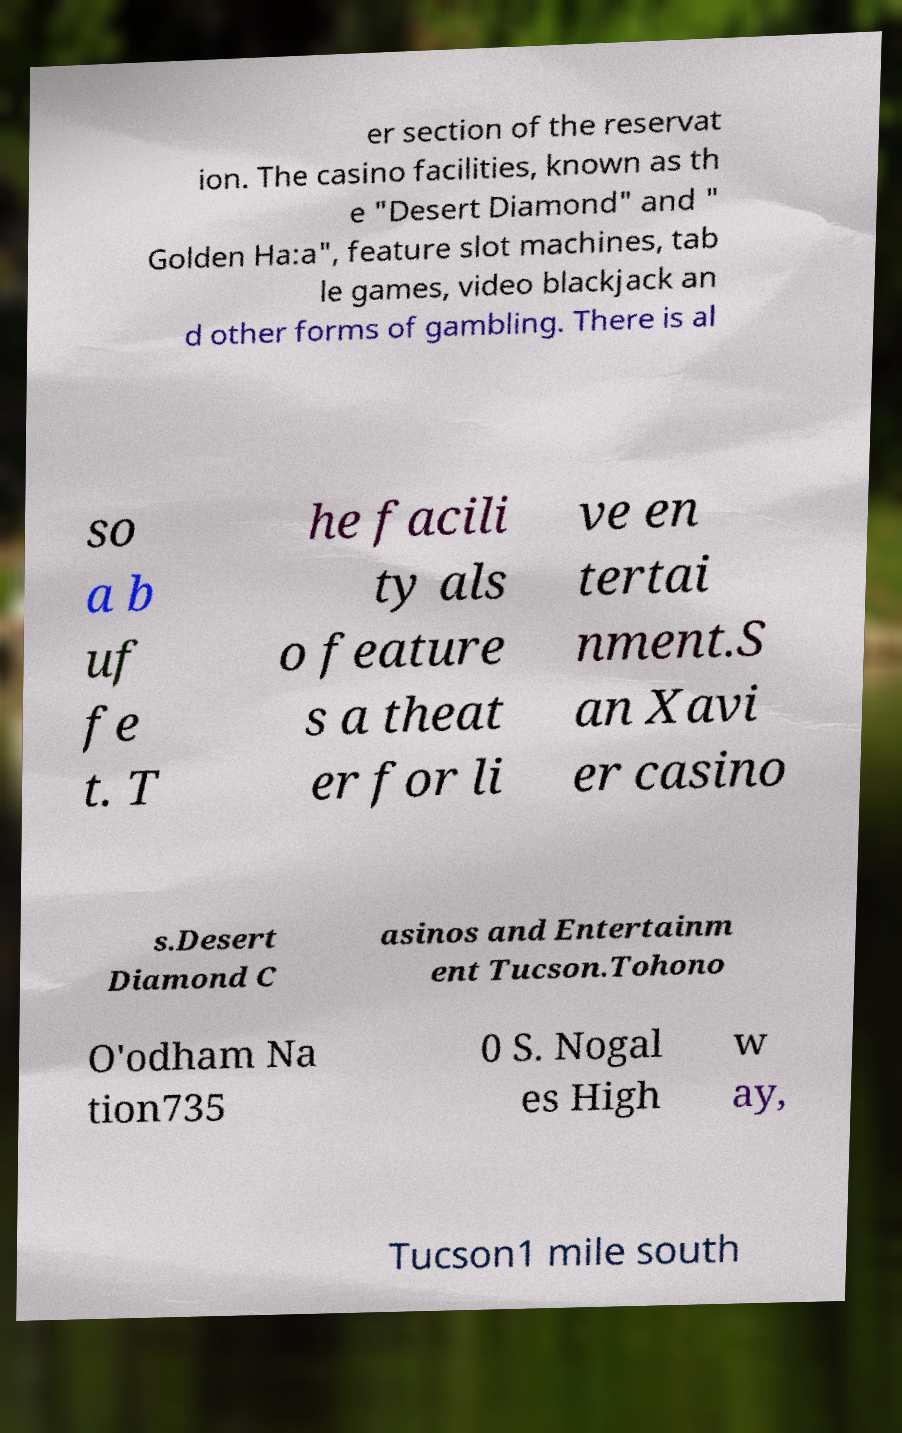There's text embedded in this image that I need extracted. Can you transcribe it verbatim? er section of the reservat ion. The casino facilities, known as th e "Desert Diamond" and " Golden Ha:a", feature slot machines, tab le games, video blackjack an d other forms of gambling. There is al so a b uf fe t. T he facili ty als o feature s a theat er for li ve en tertai nment.S an Xavi er casino s.Desert Diamond C asinos and Entertainm ent Tucson.Tohono O'odham Na tion735 0 S. Nogal es High w ay, Tucson1 mile south 